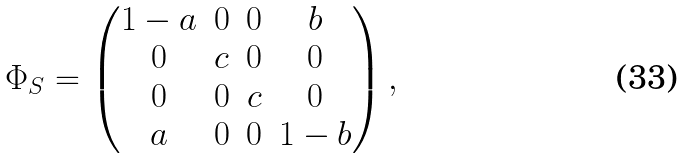<formula> <loc_0><loc_0><loc_500><loc_500>\Phi _ { S } = \begin{pmatrix} 1 - a & 0 & 0 & b \\ 0 & c & 0 & 0 \\ 0 & 0 & c & 0 \\ a & 0 & 0 & 1 - b \end{pmatrix} ,</formula> 